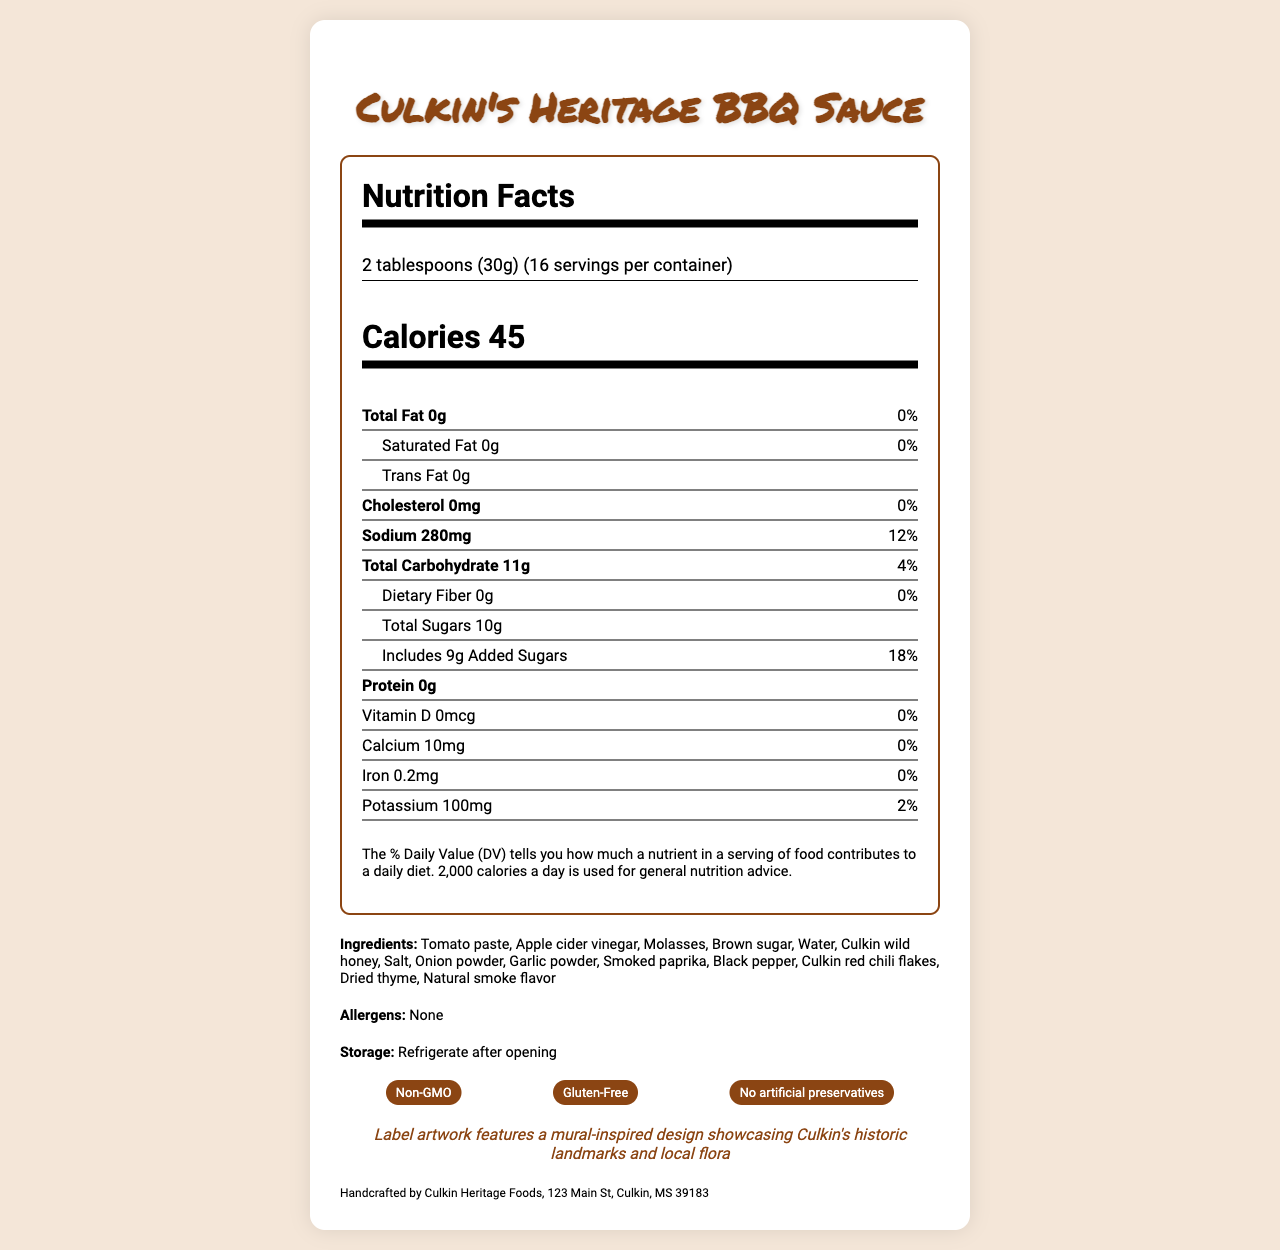what is the serving size of Culkin's Heritage BBQ Sauce? The serving size is mentioned at the beginning of the Nutrition Facts section.
Answer: 2 tablespoons (30g) how many calories are in one serving? The calorie count per serving is prominently displayed in the Nutrition Facts section.
Answer: 45 calories how many grams of total fat are in one serving? The total fat content per serving is listed as 0g in the Nutrition Facts section.
Answer: 0g how many servings are in one container? The number of servings per container is mentioned as 16 at the top of the Nutrition Facts section.
Answer: 16 what are the main ingredients in Culkin's Heritage BBQ Sauce? The ingredients are listed under the "Ingredients" section of the document.
Answer: Tomato paste, Apple cider vinegar, Molasses, Brown sugar, Water, Culkin wild honey, Salt, Onion powder, Garlic powder, Smoked paprika, Black pepper, Culkin red chili flakes, Dried thyme, Natural smoke flavor how much sodium is there per serving? The sodium content per serving is specified as 280mg in the Nutrition Facts section.
Answer: 280mg What kind of artwork is featured on the label? The artist note says that the label artwork features a mural-inspired design showcasing Culkin's historic landmarks and local flora.
Answer: A mural-inspired design showcasing Culkin's historic landmarks and local flora which nutrient has the highest percentage of daily value per serving? A. Protein B. Sodium C. Iron D. Calcium The sodium content per serving is 280mg, which is equal to 12% of the daily value, the highest listed percentage.
Answer: B. Sodium how many grams of total carbohydrate are in one serving? The total carbohydrate content per serving is listed as 11g in the Nutrition Facts section.
Answer: 11g are there any allergens listed in the ingredients? The allergens section shows "None", indicating there are no allergens listed.
Answer: No is this BBQ sauce gluten-free? The certifications section includes "Gluten-Free".
Answer: Yes which type of fat is included in Culkin's Heritage BBQ Sauce? A. Total Fat B. Saturated Fat C. Trans Fat D. None of the above The total fat, saturated fat, and trans fat are all listed as 0g.
Answer: D. None of the above is there any protein in a serving of this BBQ sauce? The protein content per serving is listed as 0g in the Nutrition Facts section.
Answer: No how is this BBQ sauce preserved? The certifications section includes "No artificial preservatives".
Answer: No artificial preservatives how much sugar is added to each serving? The Added Sugars section says there are 9g of added sugars per serving.
Answer: 9g does this BBQ sauce contain cholesterol? The cholesterol content per serving is listed as 0mg.
Answer: No how should the sauce be stored after opening? The storage instructions specify to refrigerate after opening.
Answer: Refrigerate after opening who manufactures Culkin's Heritage BBQ Sauce? The manufacturer information at the end of the document shows this.
Answer: Handcrafted by Culkin Heritage Foods, 123 Main St, Culkin, MS 39183 describe the main idea of the document. The document is a comprehensive presentation of the Culkin's Heritage BBQ Sauce nutrition facts, ingredient list, certifications, and additional product-related notes.
Answer: The document provides detailed nutritional information, ingredients, certifications, storage instructions, and additional notes about Culkin's Heritage BBQ Sauce, including the heritage-inspired label artwork. what is the recommended daily calorie intake based on this label? The daily value footnote states that 2,000 calories a day is used for general nutrition advice.
Answer: 2,000 calories what is the percentage of dietary fiber per serving? The dietary fiber content is listed as 0g, but no percentage daily value is provided for it.
Answer: Cannot be determined 